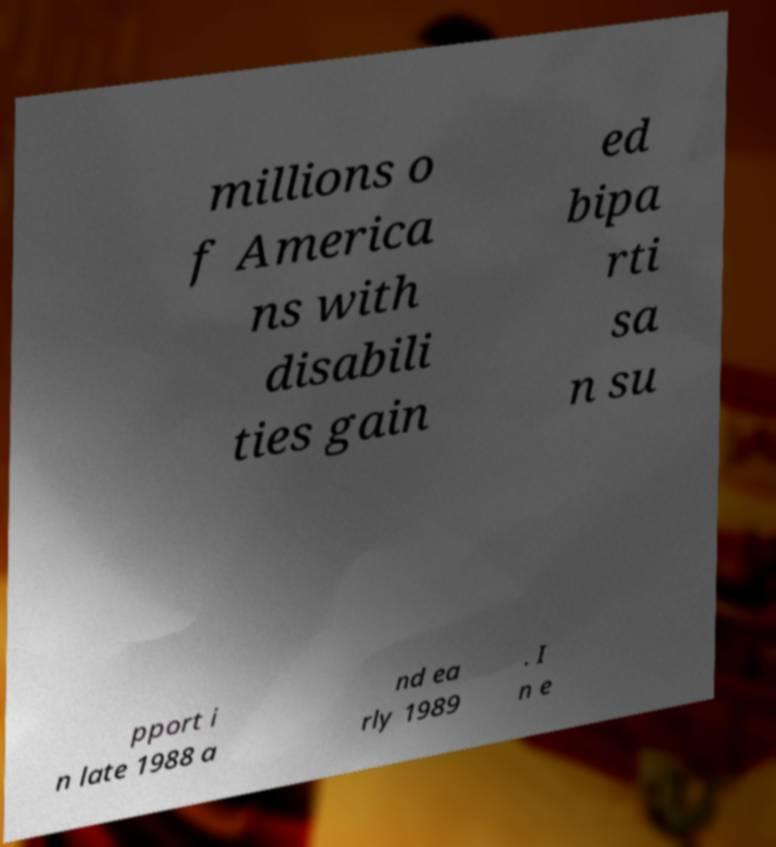Please identify and transcribe the text found in this image. millions o f America ns with disabili ties gain ed bipa rti sa n su pport i n late 1988 a nd ea rly 1989 . I n e 